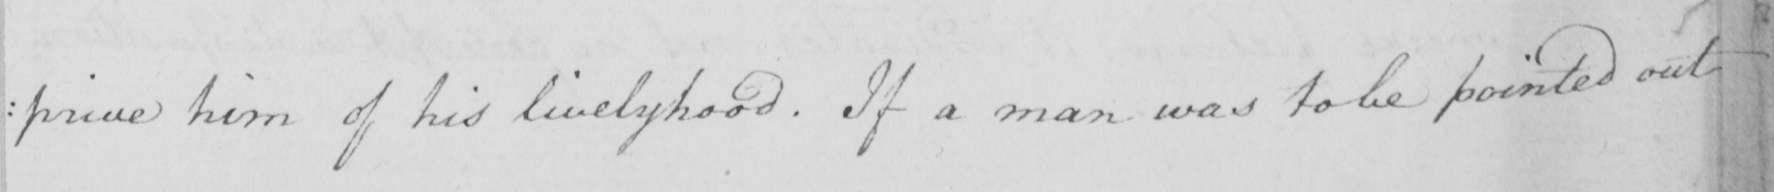Please provide the text content of this handwritten line. : prive him of his livelyhood . If a man was to be pointed out 